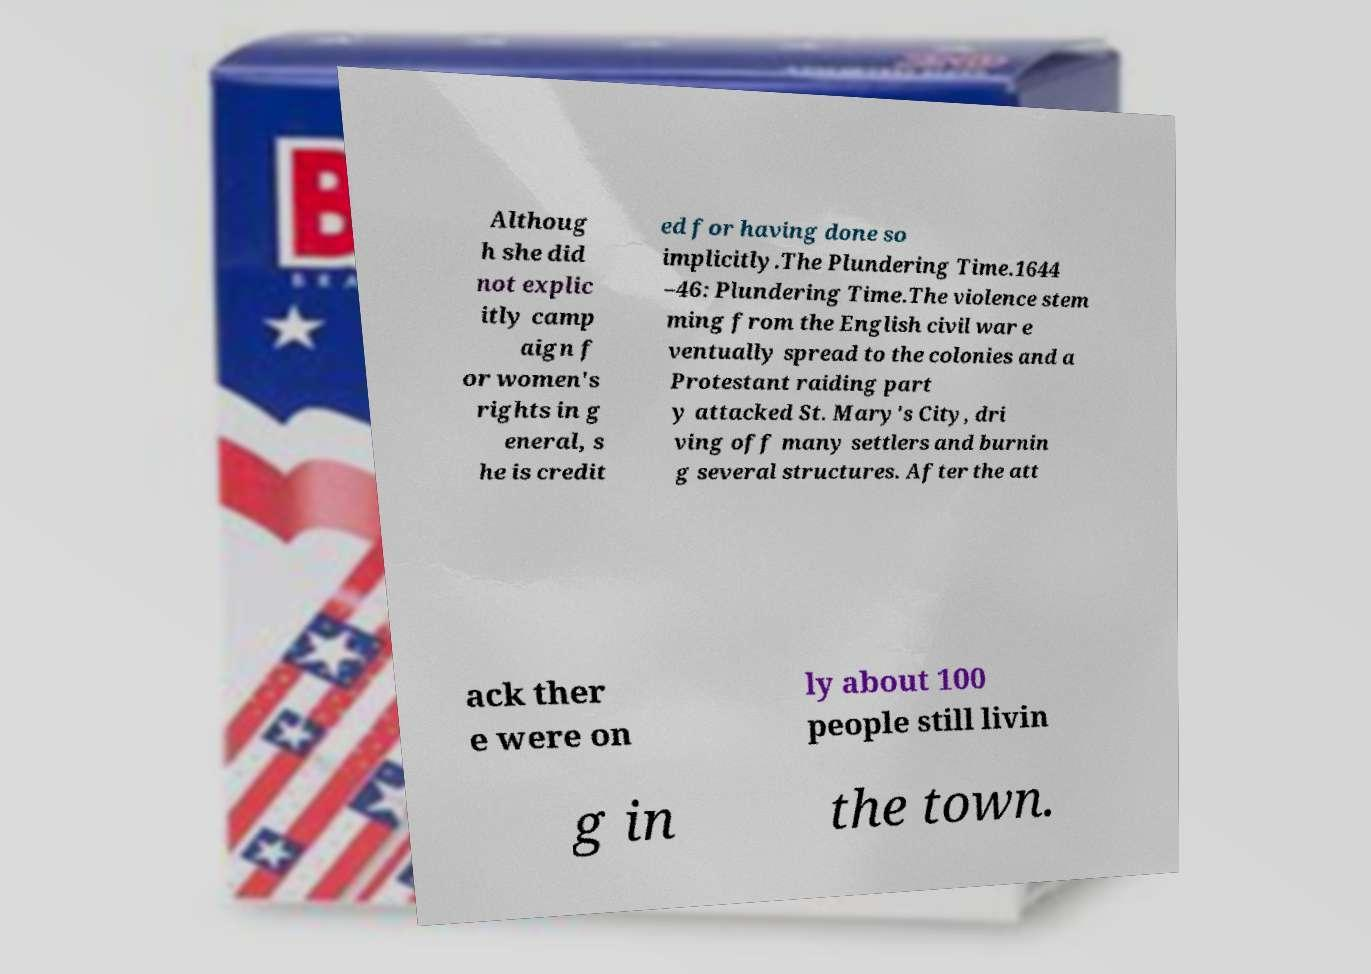I need the written content from this picture converted into text. Can you do that? Althoug h she did not explic itly camp aign f or women's rights in g eneral, s he is credit ed for having done so implicitly.The Plundering Time.1644 –46: Plundering Time.The violence stem ming from the English civil war e ventually spread to the colonies and a Protestant raiding part y attacked St. Mary's City, dri ving off many settlers and burnin g several structures. After the att ack ther e were on ly about 100 people still livin g in the town. 